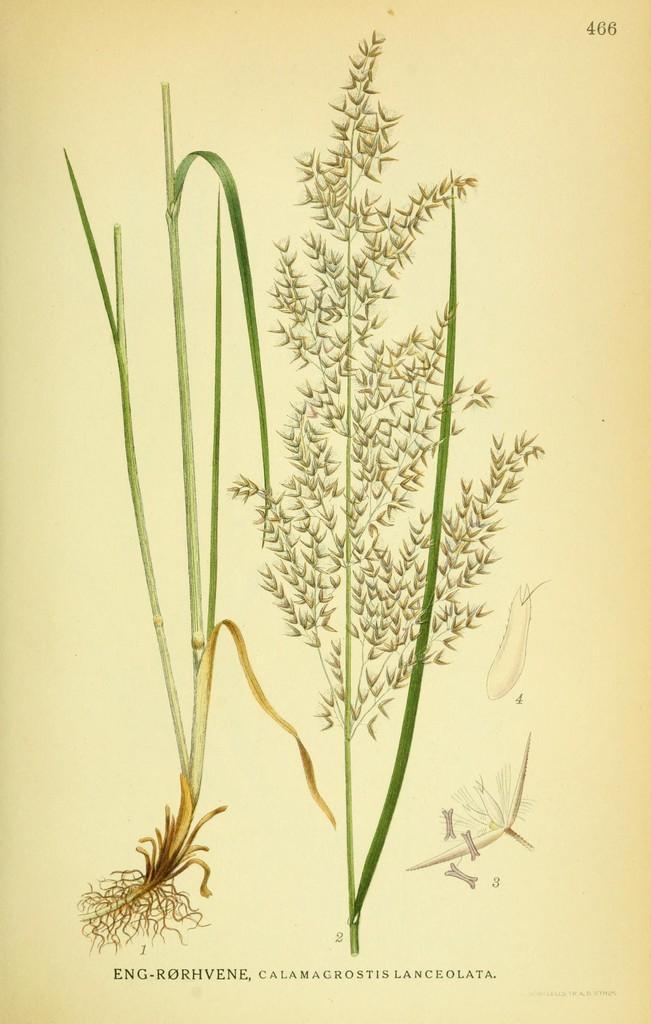Can you describe this image briefly? In this image we can see types of grass pictures on the paper. 